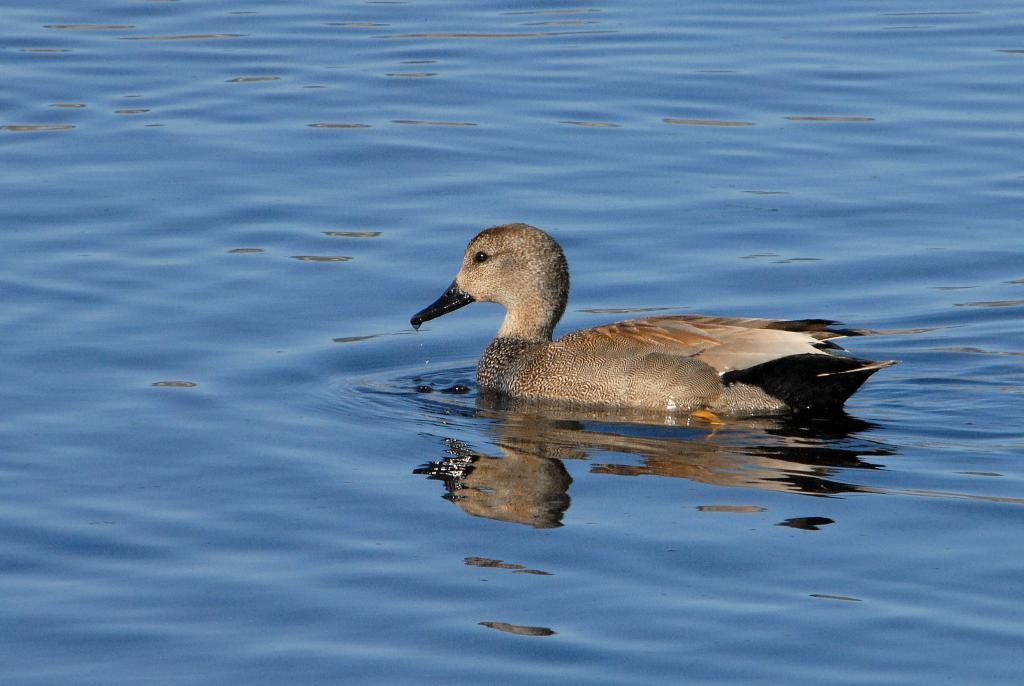What animal is present in the image? There is a duck in the image. Where is the duck located? The duck is on a water surface. What type of banana is being used as a vessel for the duck's business in the image? There is no banana, vessel, or business involving the duck in the image; it simply shows a duck on a water surface. 